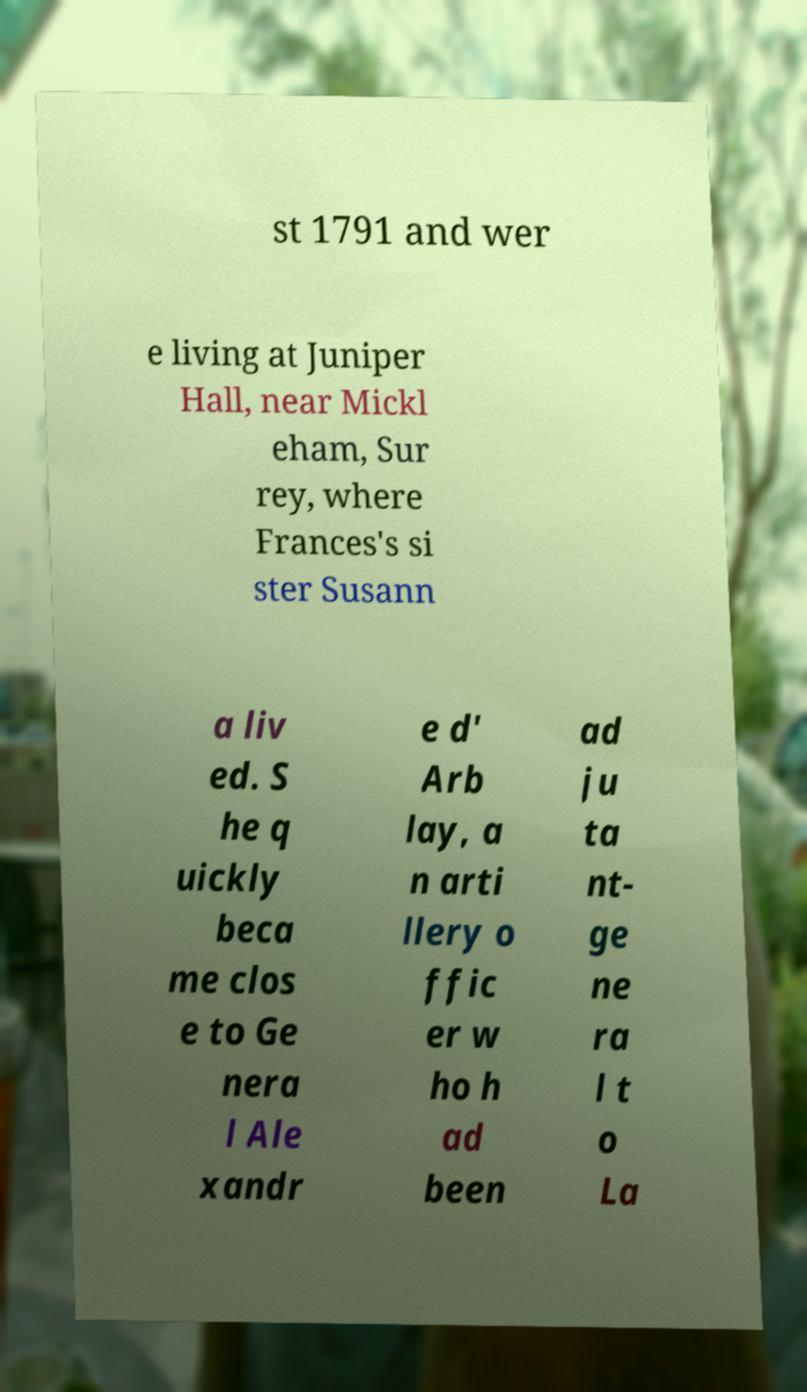For documentation purposes, I need the text within this image transcribed. Could you provide that? st 1791 and wer e living at Juniper Hall, near Mickl eham, Sur rey, where Frances's si ster Susann a liv ed. S he q uickly beca me clos e to Ge nera l Ale xandr e d' Arb lay, a n arti llery o ffic er w ho h ad been ad ju ta nt- ge ne ra l t o La 